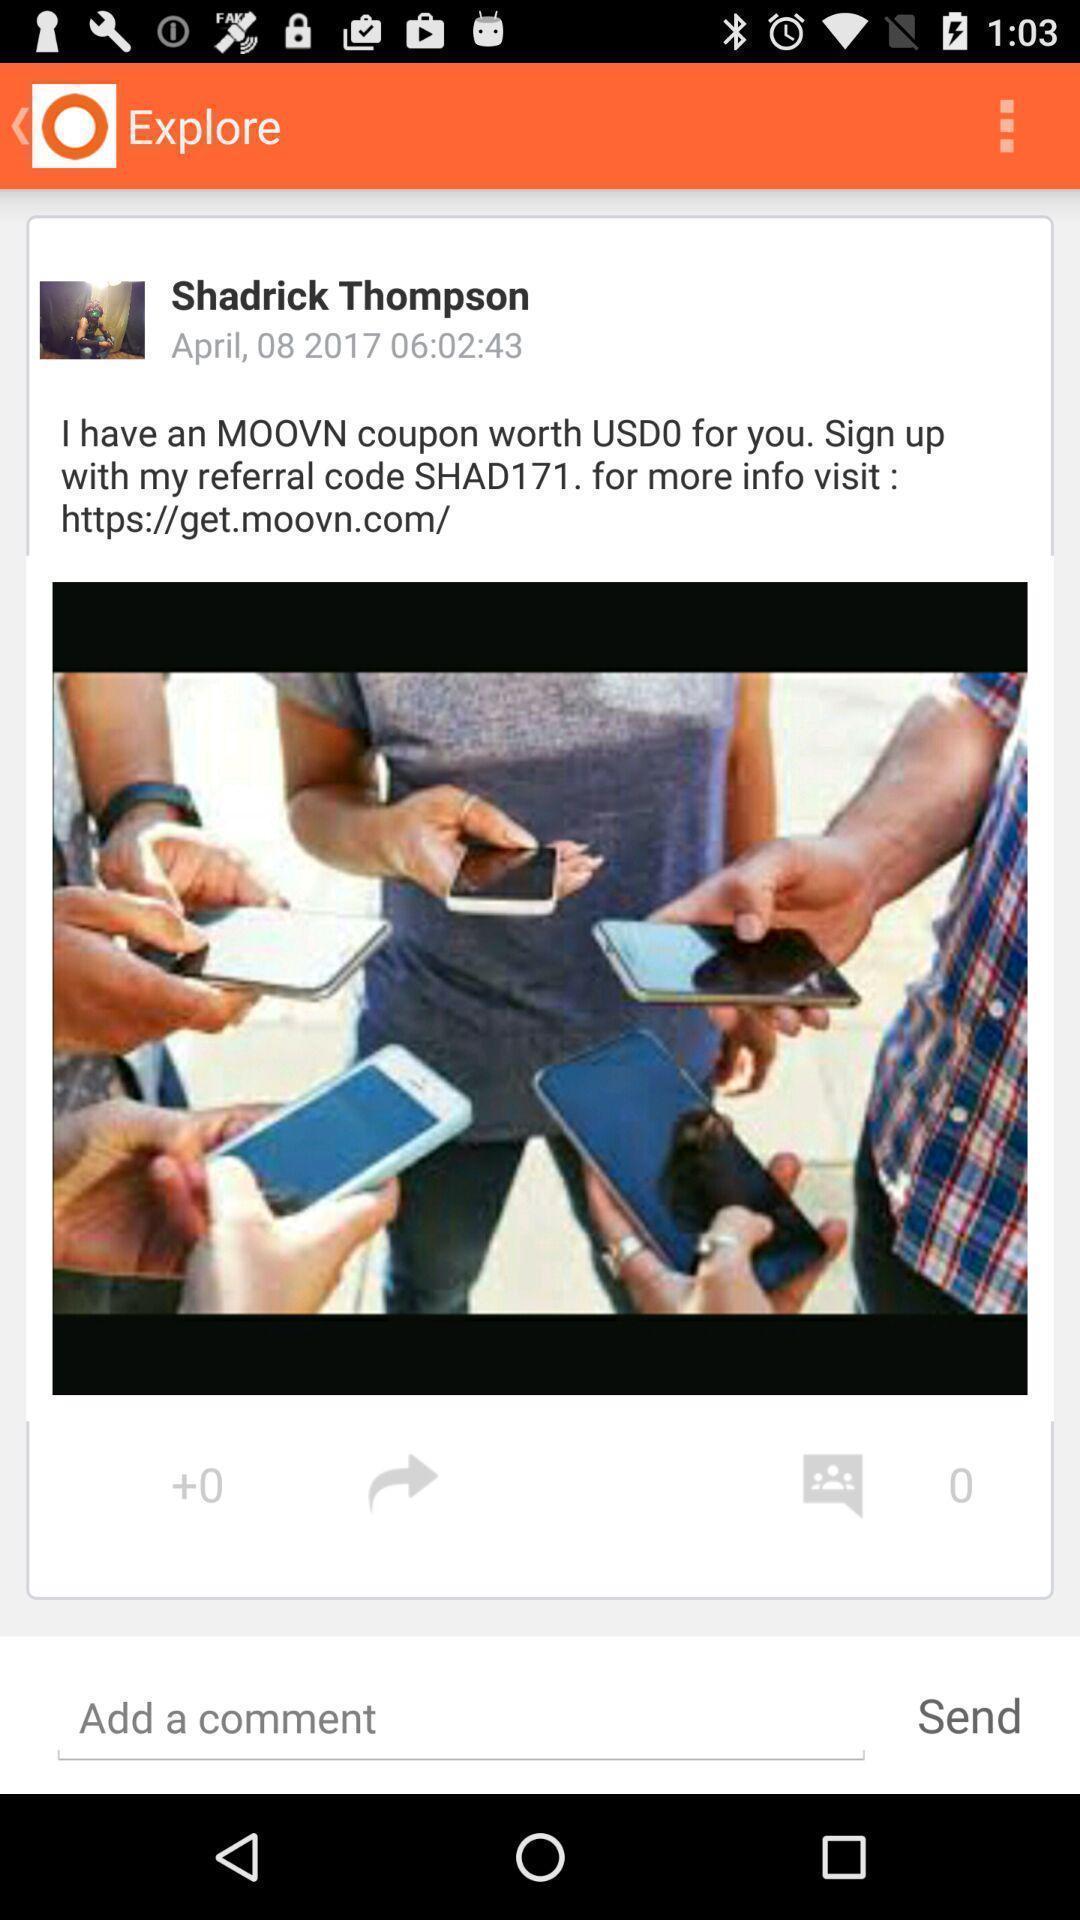Describe the content in this image. Screen shows an image in a social media app. 